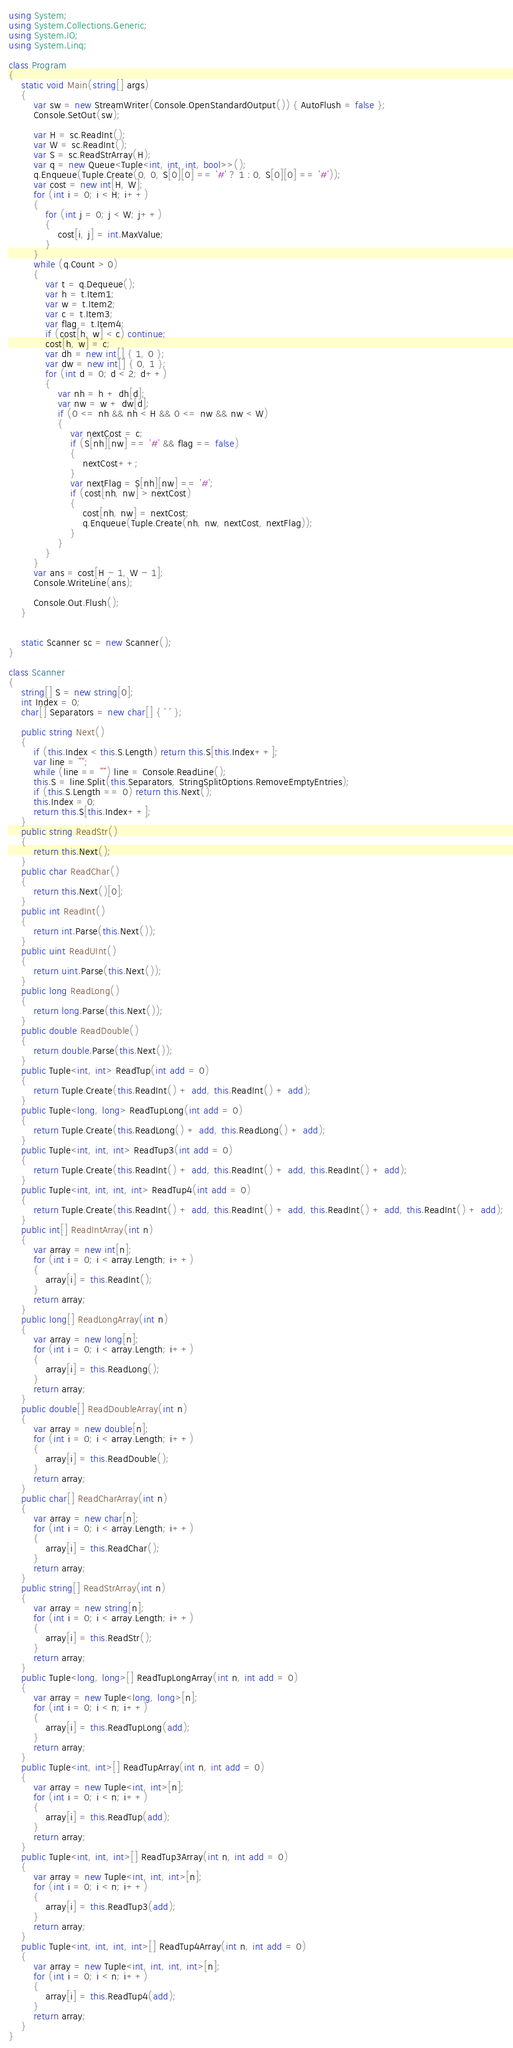<code> <loc_0><loc_0><loc_500><loc_500><_C#_>using System;
using System.Collections.Generic;
using System.IO;
using System.Linq;

class Program
{
    static void Main(string[] args)
    {
        var sw = new StreamWriter(Console.OpenStandardOutput()) { AutoFlush = false };
        Console.SetOut(sw);

        var H = sc.ReadInt();
        var W = sc.ReadInt();
        var S = sc.ReadStrArray(H);
        var q = new Queue<Tuple<int, int, int, bool>>();
        q.Enqueue(Tuple.Create(0, 0, S[0][0] == '#' ? 1 : 0, S[0][0] == '#'));
        var cost = new int[H, W];
        for (int i = 0; i < H; i++)
        {
            for (int j = 0; j < W; j++)
            {
                cost[i, j] = int.MaxValue;
            }
        }
        while (q.Count > 0)
        {
            var t = q.Dequeue();
            var h = t.Item1;
            var w = t.Item2;
            var c = t.Item3;
            var flag = t.Item4;
            if (cost[h, w] < c) continue;
            cost[h, w] = c;
            var dh = new int[] { 1, 0 };
            var dw = new int[] { 0, 1 };
            for (int d = 0; d < 2; d++)
            {
                var nh = h + dh[d];
                var nw = w + dw[d];
                if (0 <= nh && nh < H && 0 <= nw && nw < W)
                {
                    var nextCost = c;
                    if (S[nh][nw] == '#' && flag == false)
                    {
                        nextCost++;
                    }
                    var nextFlag = S[nh][nw] == '#';
                    if (cost[nh, nw] > nextCost)
                    {
                        cost[nh, nw] = nextCost;
                        q.Enqueue(Tuple.Create(nh, nw, nextCost, nextFlag));
                    }
                }
            }
        }
        var ans = cost[H - 1, W - 1];
        Console.WriteLine(ans);

        Console.Out.Flush();
    }


    static Scanner sc = new Scanner();
}

class Scanner
{
    string[] S = new string[0];
    int Index = 0;
    char[] Separators = new char[] { ' ' };

    public string Next()
    {
        if (this.Index < this.S.Length) return this.S[this.Index++];
        var line = "";
        while (line == "") line = Console.ReadLine();
        this.S = line.Split(this.Separators, StringSplitOptions.RemoveEmptyEntries);
        if (this.S.Length == 0) return this.Next();
        this.Index = 0;
        return this.S[this.Index++];
    }
    public string ReadStr()
    {
        return this.Next();
    }
    public char ReadChar()
    {
        return this.Next()[0];
    }
    public int ReadInt()
    {
        return int.Parse(this.Next());
    }
    public uint ReadUInt()
    {
        return uint.Parse(this.Next());
    }
    public long ReadLong()
    {
        return long.Parse(this.Next());
    }
    public double ReadDouble()
    {
        return double.Parse(this.Next());
    }
    public Tuple<int, int> ReadTup(int add = 0)
    {
        return Tuple.Create(this.ReadInt() + add, this.ReadInt() + add);
    }
    public Tuple<long, long> ReadTupLong(int add = 0)
    {
        return Tuple.Create(this.ReadLong() + add, this.ReadLong() + add);
    }
    public Tuple<int, int, int> ReadTup3(int add = 0)
    {
        return Tuple.Create(this.ReadInt() + add, this.ReadInt() + add, this.ReadInt() + add);
    }
    public Tuple<int, int, int, int> ReadTup4(int add = 0)
    {
        return Tuple.Create(this.ReadInt() + add, this.ReadInt() + add, this.ReadInt() + add, this.ReadInt() + add);
    }
    public int[] ReadIntArray(int n)
    {
        var array = new int[n];
        for (int i = 0; i < array.Length; i++)
        {
            array[i] = this.ReadInt();
        }
        return array;
    }
    public long[] ReadLongArray(int n)
    {
        var array = new long[n];
        for (int i = 0; i < array.Length; i++)
        {
            array[i] = this.ReadLong();
        }
        return array;
    }
    public double[] ReadDoubleArray(int n)
    {
        var array = new double[n];
        for (int i = 0; i < array.Length; i++)
        {
            array[i] = this.ReadDouble();
        }
        return array;
    }
    public char[] ReadCharArray(int n)
    {
        var array = new char[n];
        for (int i = 0; i < array.Length; i++)
        {
            array[i] = this.ReadChar();
        }
        return array;
    }
    public string[] ReadStrArray(int n)
    {
        var array = new string[n];
        for (int i = 0; i < array.Length; i++)
        {
            array[i] = this.ReadStr();
        }
        return array;
    }
    public Tuple<long, long>[] ReadTupLongArray(int n, int add = 0)
    {
        var array = new Tuple<long, long>[n];
        for (int i = 0; i < n; i++)
        {
            array[i] = this.ReadTupLong(add);
        }
        return array;
    }
    public Tuple<int, int>[] ReadTupArray(int n, int add = 0)
    {
        var array = new Tuple<int, int>[n];
        for (int i = 0; i < n; i++)
        {
            array[i] = this.ReadTup(add);
        }
        return array;
    }
    public Tuple<int, int, int>[] ReadTup3Array(int n, int add = 0)
    {
        var array = new Tuple<int, int, int>[n];
        for (int i = 0; i < n; i++)
        {
            array[i] = this.ReadTup3(add);
        }
        return array;
    }
    public Tuple<int, int, int, int>[] ReadTup4Array(int n, int add = 0)
    {
        var array = new Tuple<int, int, int, int>[n];
        for (int i = 0; i < n; i++)
        {
            array[i] = this.ReadTup4(add);
        }
        return array;
    }
}
</code> 